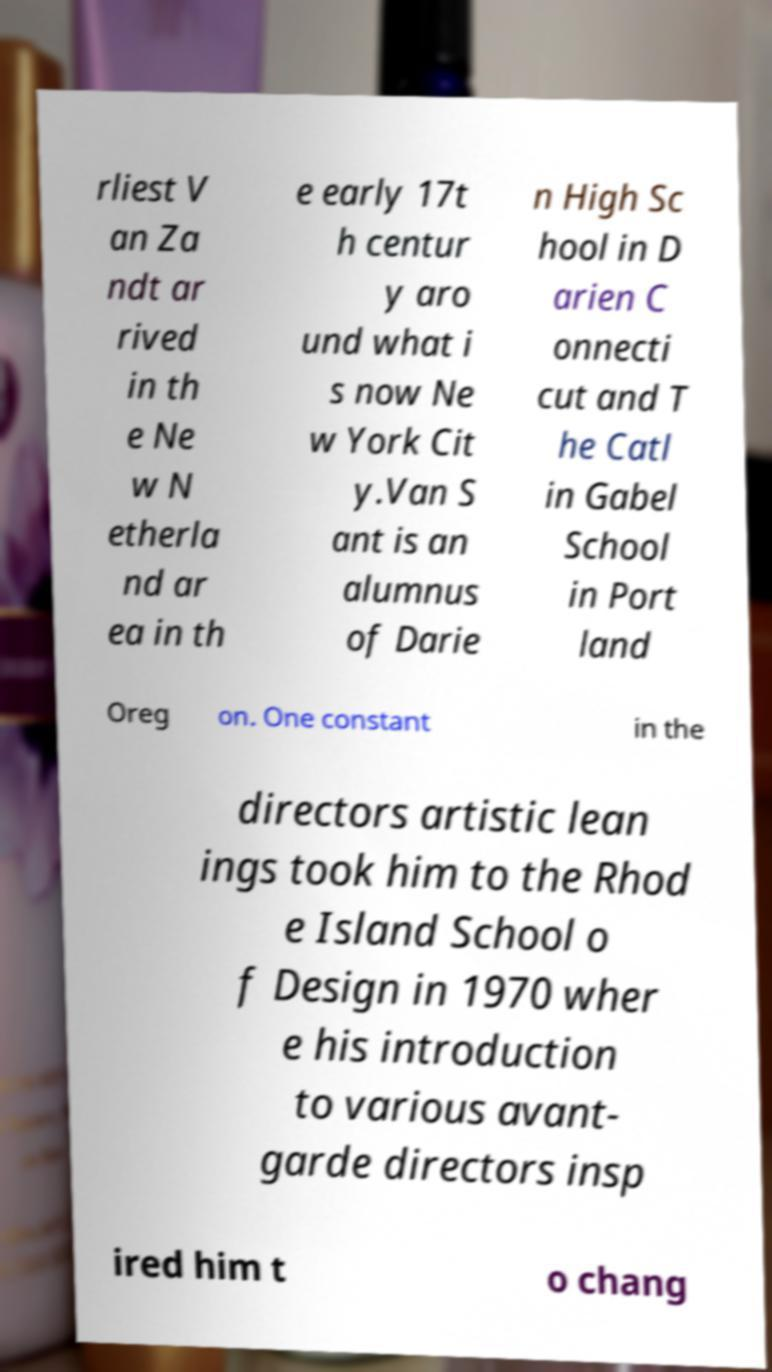Please read and relay the text visible in this image. What does it say? rliest V an Za ndt ar rived in th e Ne w N etherla nd ar ea in th e early 17t h centur y aro und what i s now Ne w York Cit y.Van S ant is an alumnus of Darie n High Sc hool in D arien C onnecti cut and T he Catl in Gabel School in Port land Oreg on. One constant in the directors artistic lean ings took him to the Rhod e Island School o f Design in 1970 wher e his introduction to various avant- garde directors insp ired him t o chang 